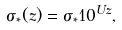Convert formula to latex. <formula><loc_0><loc_0><loc_500><loc_500>\sigma _ { * } ( z ) = \sigma _ { * } 1 0 ^ { U z } ,</formula> 